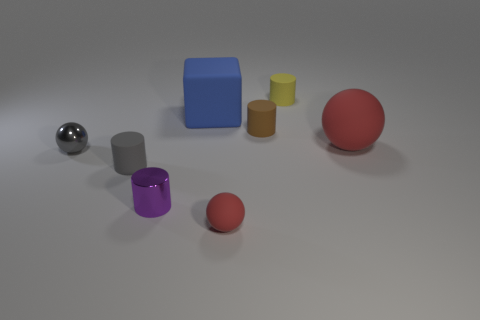Subtract all small balls. How many balls are left? 1 Add 1 rubber objects. How many objects exist? 9 Subtract all gray balls. How many balls are left? 2 Subtract all cyan blocks. How many yellow cylinders are left? 1 Subtract all small brown cylinders. Subtract all purple things. How many objects are left? 6 Add 5 purple shiny objects. How many purple shiny objects are left? 6 Add 4 small matte things. How many small matte things exist? 8 Subtract 0 green blocks. How many objects are left? 8 Subtract all balls. How many objects are left? 5 Subtract 1 spheres. How many spheres are left? 2 